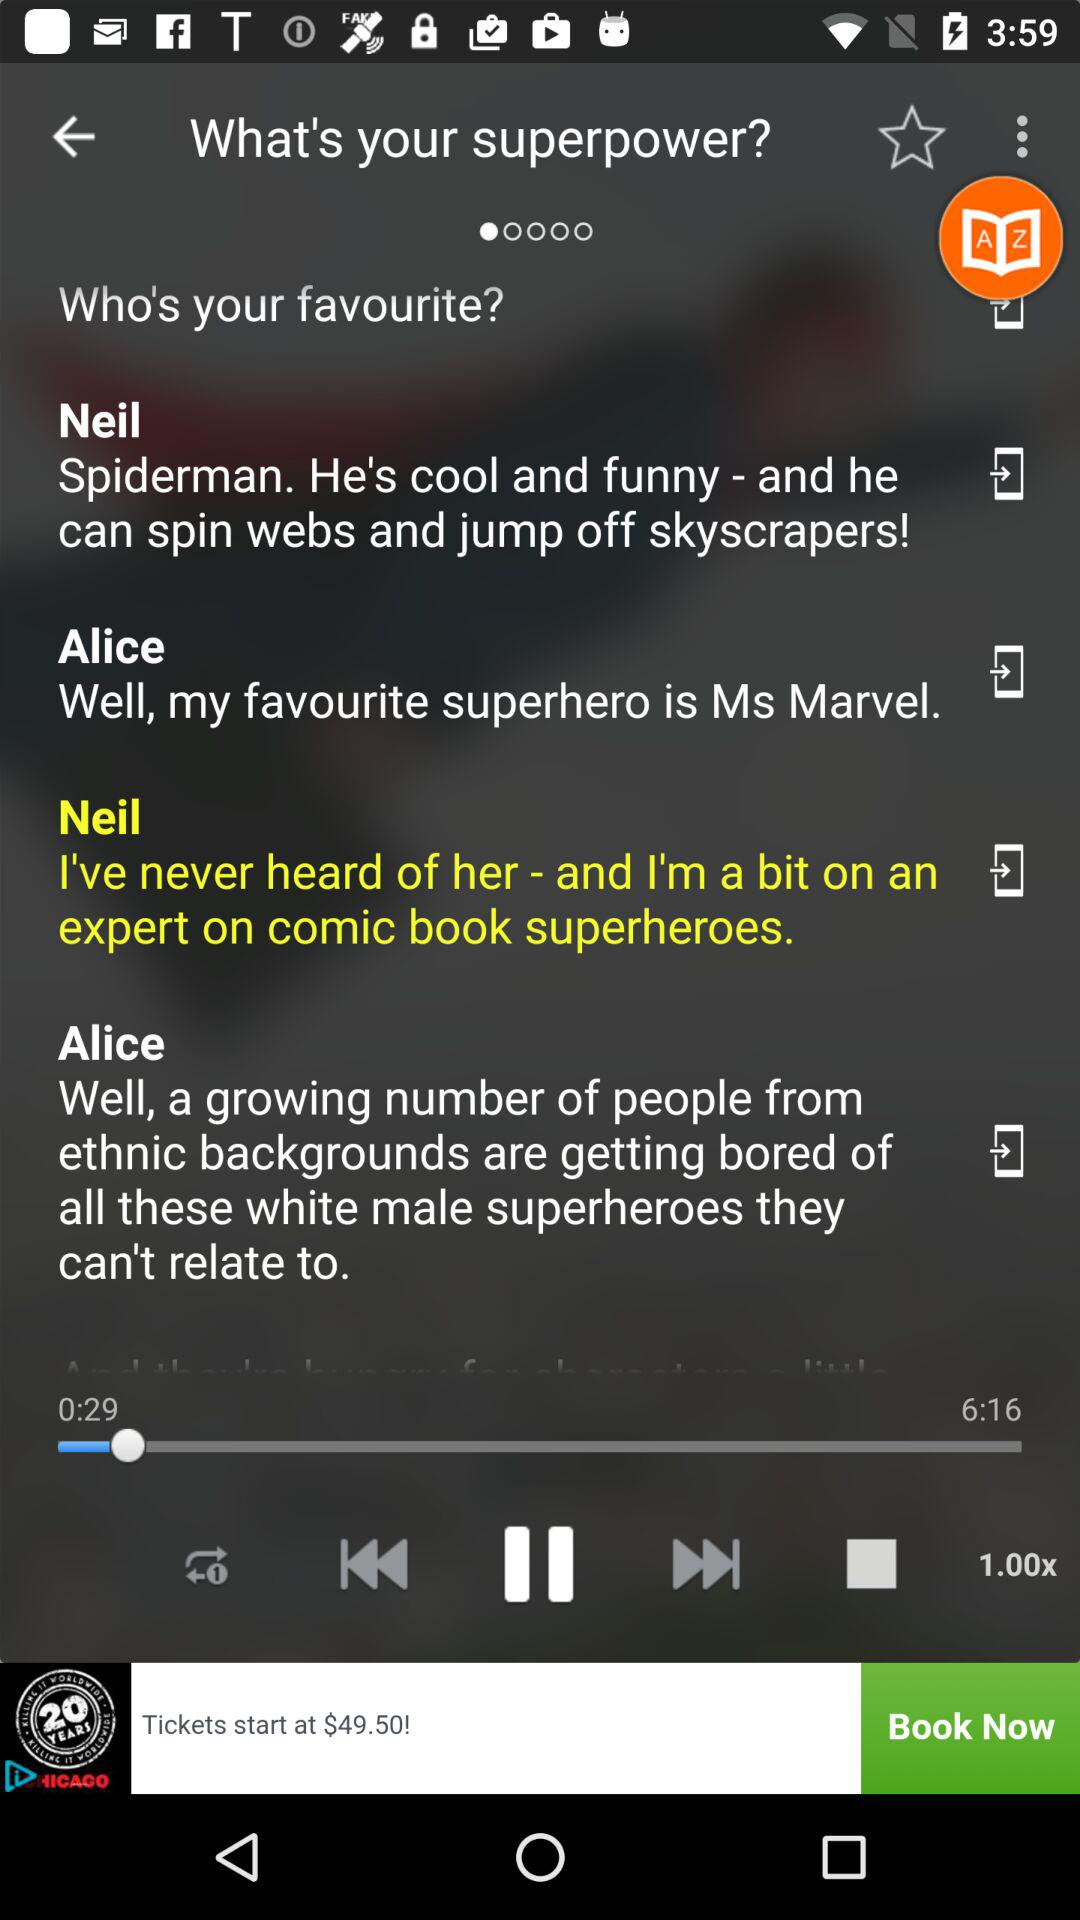What is the track playing speed? The track playing speed is 1x. 